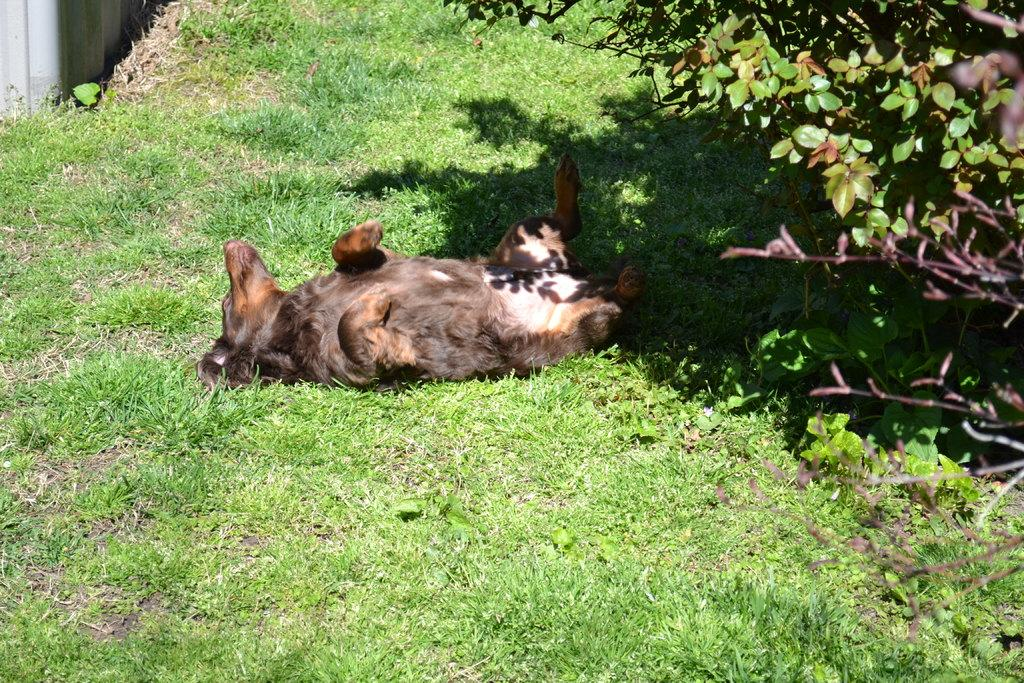What type of animal is on the ground in the image? The facts do not specify the type of animal, so we cannot definitively answer this question. What can be seen on the right side of the image? There are trees on the right side of the image. What is located on the left side of the image? There is a wall on the left side of the image. What subject is the animal teaching in the image? There is no indication in the image that the animal is teaching a subject, as animals do not typically engage in teaching activities. 